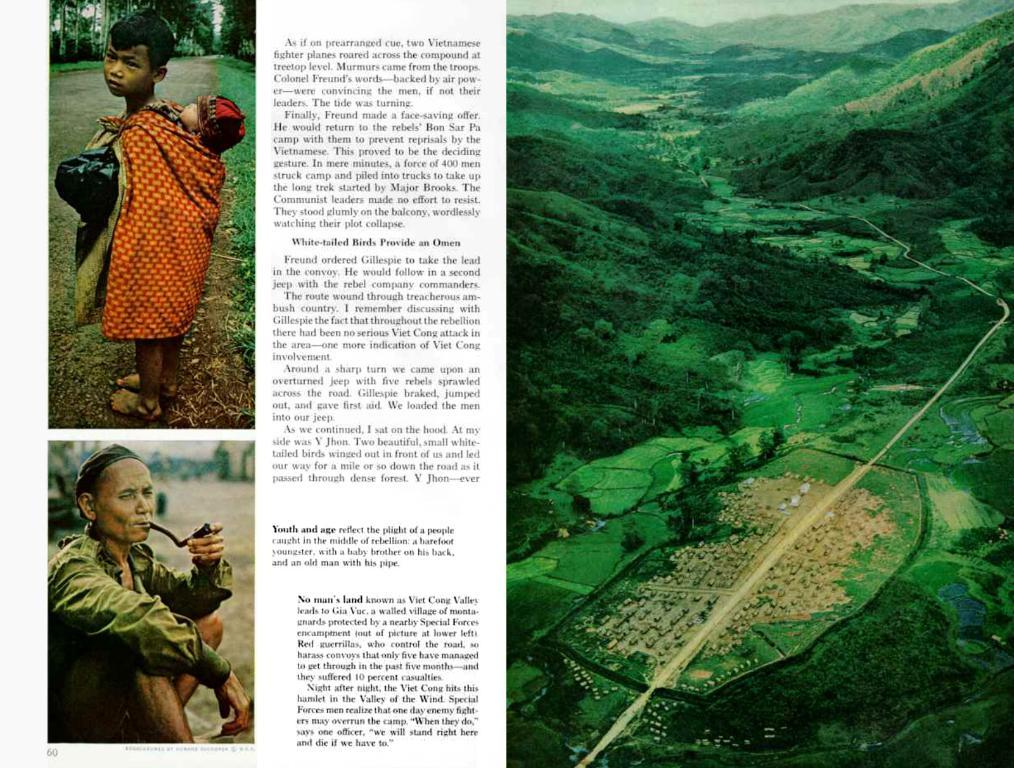What is the main subject of the image? The main subject of the image is an article. What types of content are included in the article? The article contains pictures and text. What type of quill is used to write the article in the image? There is no quill present in the image, as the article is likely created using modern technology. How does the article participate in the competition mentioned in the image? There is no mention of a competition in the image, so it cannot be determined how the article participates in one. 